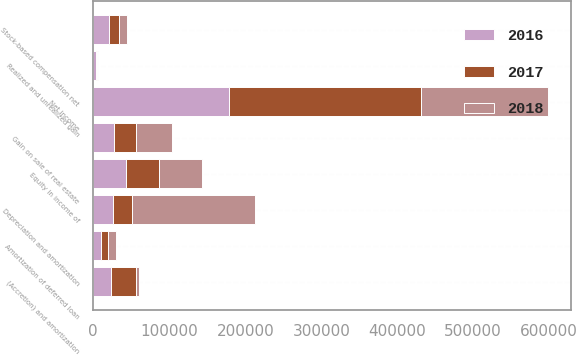Convert chart. <chart><loc_0><loc_0><loc_500><loc_500><stacked_bar_chart><ecel><fcel>Net income<fcel>Depreciation and amortization<fcel>Amortization of deferred loan<fcel>(Accretion) and amortization<fcel>Stock-based compensation net<fcel>Equity in income of<fcel>Gain on sale of real estate<fcel>Realized and unrealized gain<nl><fcel>2017<fcel>252325<fcel>25288<fcel>10476<fcel>33330<fcel>13635<fcel>42974<fcel>28343<fcel>1177<nl><fcel>2016<fcel>178980<fcel>25288<fcel>9509<fcel>23144<fcel>20549<fcel>43341<fcel>27432<fcel>3844<nl><fcel>2018<fcel>166992<fcel>162327<fcel>9762<fcel>3879<fcel>10652<fcel>56518<fcel>47321<fcel>1655<nl></chart> 